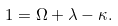<formula> <loc_0><loc_0><loc_500><loc_500>1 = \Omega + \lambda - \kappa .</formula> 